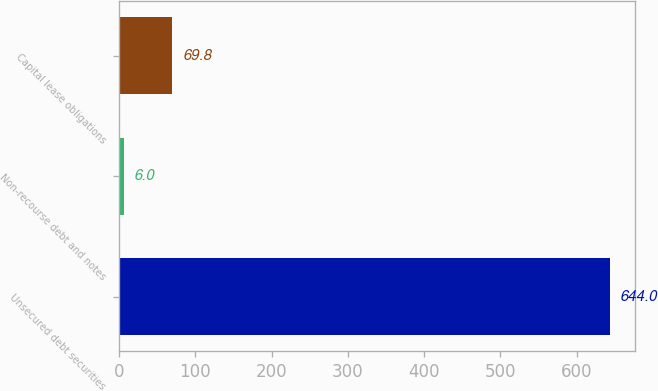<chart> <loc_0><loc_0><loc_500><loc_500><bar_chart><fcel>Unsecured debt securities<fcel>Non-recourse debt and notes<fcel>Capital lease obligations<nl><fcel>644<fcel>6<fcel>69.8<nl></chart> 